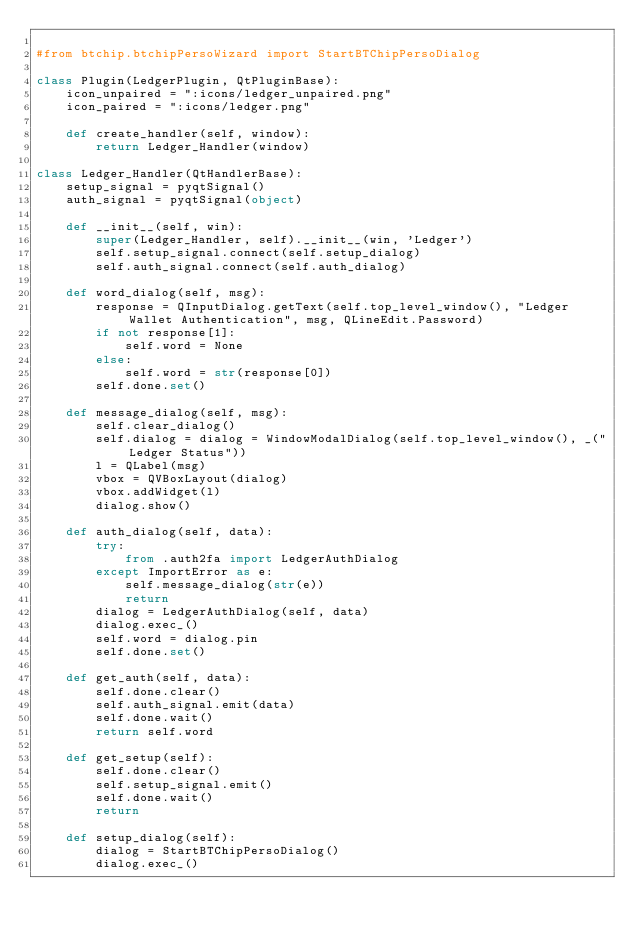Convert code to text. <code><loc_0><loc_0><loc_500><loc_500><_Python_>
#from btchip.btchipPersoWizard import StartBTChipPersoDialog

class Plugin(LedgerPlugin, QtPluginBase):
    icon_unpaired = ":icons/ledger_unpaired.png"
    icon_paired = ":icons/ledger.png"

    def create_handler(self, window):
        return Ledger_Handler(window)

class Ledger_Handler(QtHandlerBase):
    setup_signal = pyqtSignal()
    auth_signal = pyqtSignal(object)

    def __init__(self, win):
        super(Ledger_Handler, self).__init__(win, 'Ledger')
        self.setup_signal.connect(self.setup_dialog)
        self.auth_signal.connect(self.auth_dialog)

    def word_dialog(self, msg):
        response = QInputDialog.getText(self.top_level_window(), "Ledger Wallet Authentication", msg, QLineEdit.Password)
        if not response[1]:
            self.word = None
        else:
            self.word = str(response[0])
        self.done.set()
    
    def message_dialog(self, msg):
        self.clear_dialog()
        self.dialog = dialog = WindowModalDialog(self.top_level_window(), _("Ledger Status"))
        l = QLabel(msg)
        vbox = QVBoxLayout(dialog)
        vbox.addWidget(l)
        dialog.show()

    def auth_dialog(self, data):
        try:
            from .auth2fa import LedgerAuthDialog
        except ImportError as e:
            self.message_dialog(str(e))
            return
        dialog = LedgerAuthDialog(self, data)
        dialog.exec_()
        self.word = dialog.pin
        self.done.set()
                    
    def get_auth(self, data):
        self.done.clear()
        self.auth_signal.emit(data)
        self.done.wait()
        return self.word
        
    def get_setup(self):
        self.done.clear()
        self.setup_signal.emit()
        self.done.wait()
        return 
        
    def setup_dialog(self):
        dialog = StartBTChipPersoDialog()
        dialog.exec_()


        
        
        
        
</code> 